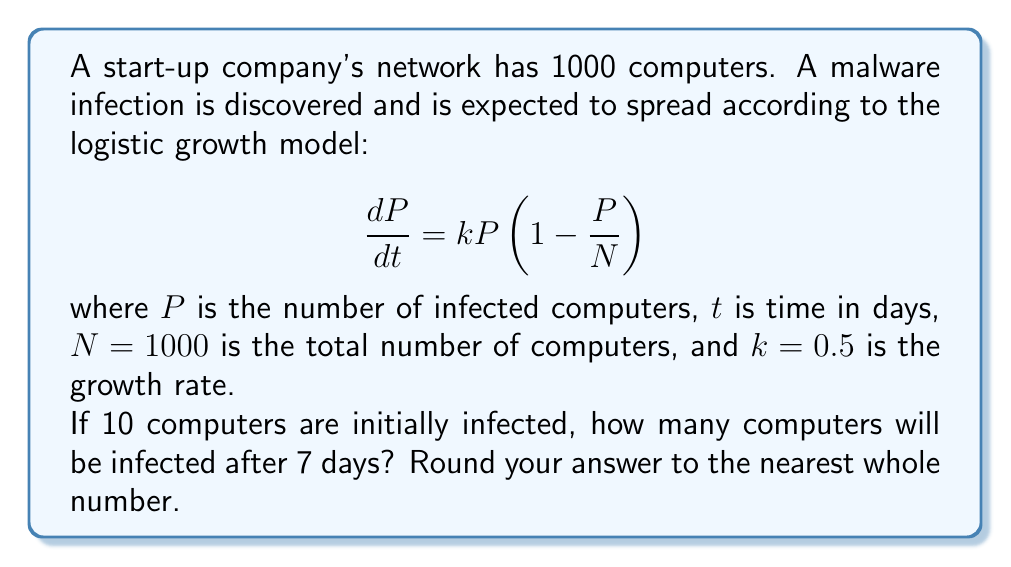Help me with this question. Let's solve this step-by-step:

1) The logistic growth model is given by the differential equation:

   $$\frac{dP}{dt} = kP(1-\frac{P}{N})$$

2) The solution to this equation is:

   $$P(t) = \frac{N}{1 + (\frac{N}{P_0} - 1)e^{-kt}}$$

   where $P_0$ is the initial number of infected computers.

3) We're given:
   - $N = 1000$ (total computers)
   - $k = 0.5$ (growth rate)
   - $P_0 = 10$ (initial infected computers)
   - $t = 7$ (days)

4) Let's substitute these values into our solution:

   $$P(7) = \frac{1000}{1 + (\frac{1000}{10} - 1)e^{-0.5 \cdot 7}}$$

5) Simplify:
   $$P(7) = \frac{1000}{1 + 99e^{-3.5}}$$

6) Calculate:
   $$P(7) = \frac{1000}{1 + 99 \cdot 0.0302} \approx 767.52$$

7) Rounding to the nearest whole number:
   $$P(7) \approx 768$$
Answer: 768 computers 